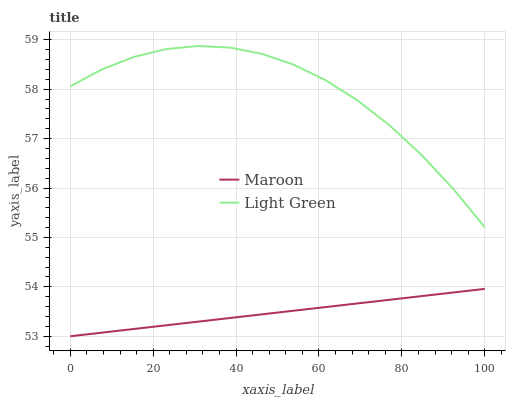Does Maroon have the minimum area under the curve?
Answer yes or no. Yes. Does Light Green have the maximum area under the curve?
Answer yes or no. Yes. Does Maroon have the maximum area under the curve?
Answer yes or no. No. Is Maroon the smoothest?
Answer yes or no. Yes. Is Light Green the roughest?
Answer yes or no. Yes. Is Maroon the roughest?
Answer yes or no. No. Does Light Green have the highest value?
Answer yes or no. Yes. Does Maroon have the highest value?
Answer yes or no. No. Is Maroon less than Light Green?
Answer yes or no. Yes. Is Light Green greater than Maroon?
Answer yes or no. Yes. Does Maroon intersect Light Green?
Answer yes or no. No. 